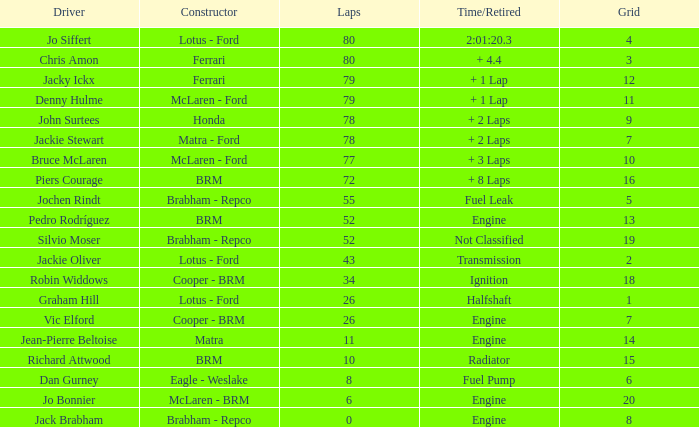When the driver richard attwood has a builder of brm, what is the count of laps? 10.0. 